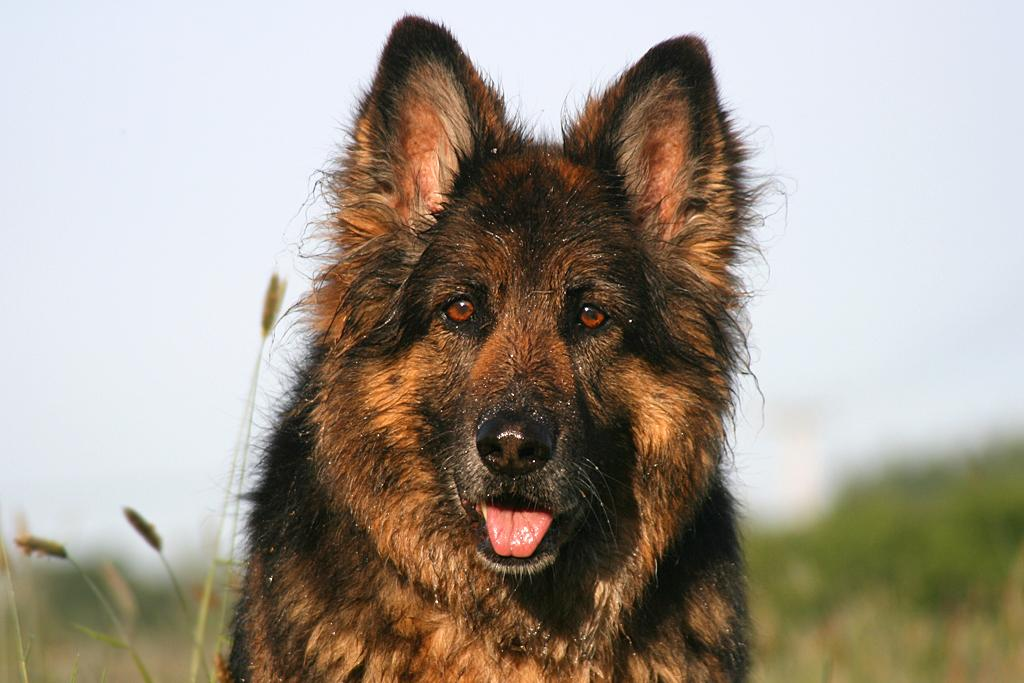What is the main subject of the image? The main subject of the image is a dog. Where is the dog located in the image? The dog is in the middle of the image. What is the color of the dog? The dog is brown in color. What type of ground is visible at the bottom of the image? There is grass at the bottom of the image. What type of shop can be seen in the background of the image? There is no shop present in the image; it features a dog in the middle of the grass. Is the island visible in the image? There is no island present in the image. 